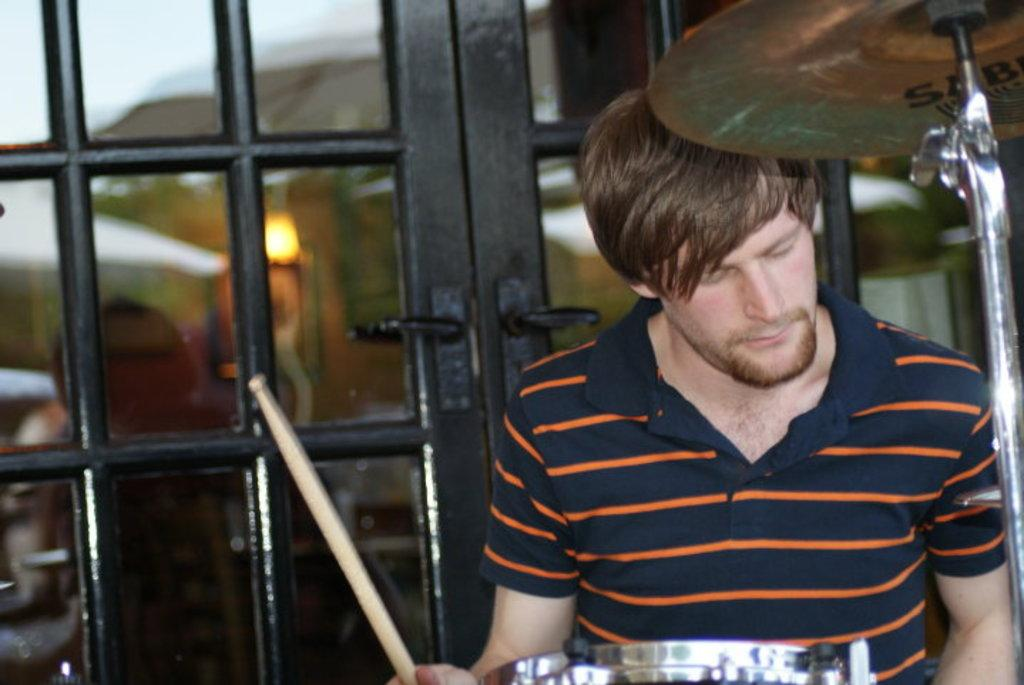What is the person in the image doing? The person is playing drums. How is the person positioned while playing drums? The person is standing while playing drums. What can be seen in the background of the image? There are doors visible in the background of the image. What is the person wearing? The person is wearing a Striped T-shirt. What type of bucket is the person using to play the drums in the image? There is no bucket present in the image; the person is playing drums with drumsticks. What kind of club does the person belong to while playing drums in the image? There is no information about the person belonging to a club in the image. 